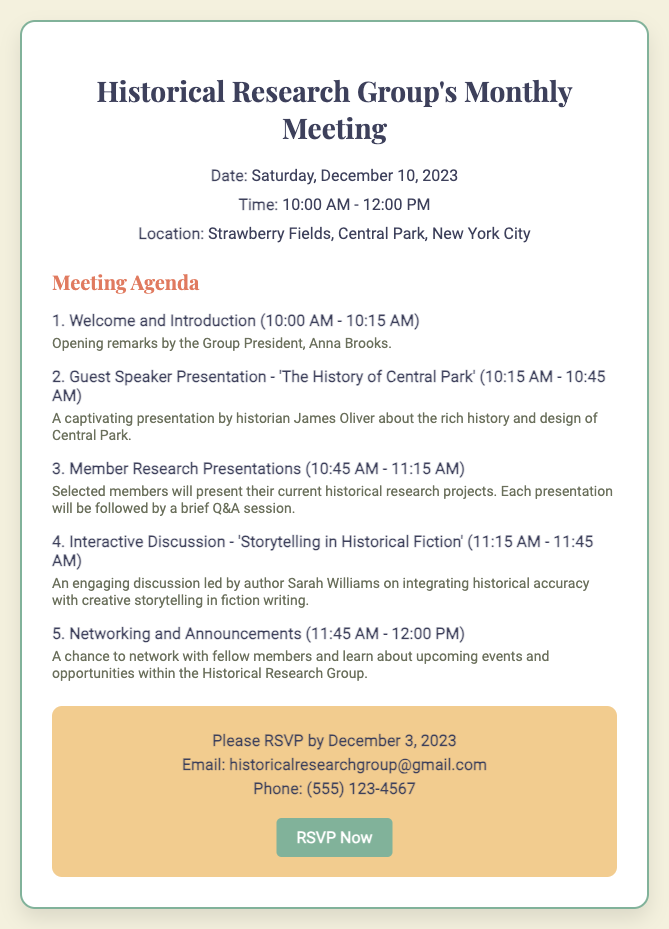what is the date of the meeting? The date of the meeting is explicitly provided in the document as "Saturday, December 10, 2023."
Answer: Saturday, December 10, 2023 what time does the meeting start? The starting time of the meeting is mentioned in the details section, which states "10:00 AM."
Answer: 10:00 AM who is the guest speaker? The document specifies the guest speaker as "historian James Oliver" who will present on "The History of Central Park."
Answer: James Oliver what is the topic of the interactive discussion? The topic is included in the agenda section as "Storytelling in Historical Fiction."
Answer: Storytelling in Historical Fiction what is the RSVP deadline? The RSVP deadline is mentioned in the action section as "December 3, 2023."
Answer: December 3, 2023 how long is the guest speaker presentation? The duration of the guest speaker presentation is listed as "30 minutes."
Answer: 30 minutes where is the meeting location? The location of the meeting is clearly stated in the document as "Strawberry Fields, Central Park, New York City."
Answer: Strawberry Fields, Central Park, New York City how many agenda items are there? By counting the agenda items listed in the agenda section, there are a total of five agenda items.
Answer: Five what is the primary purpose of the meeting? The document indicates that the meeting is a gathering for members to share and discuss historical research and storytelling.
Answer: Sharing and discussing historical research 